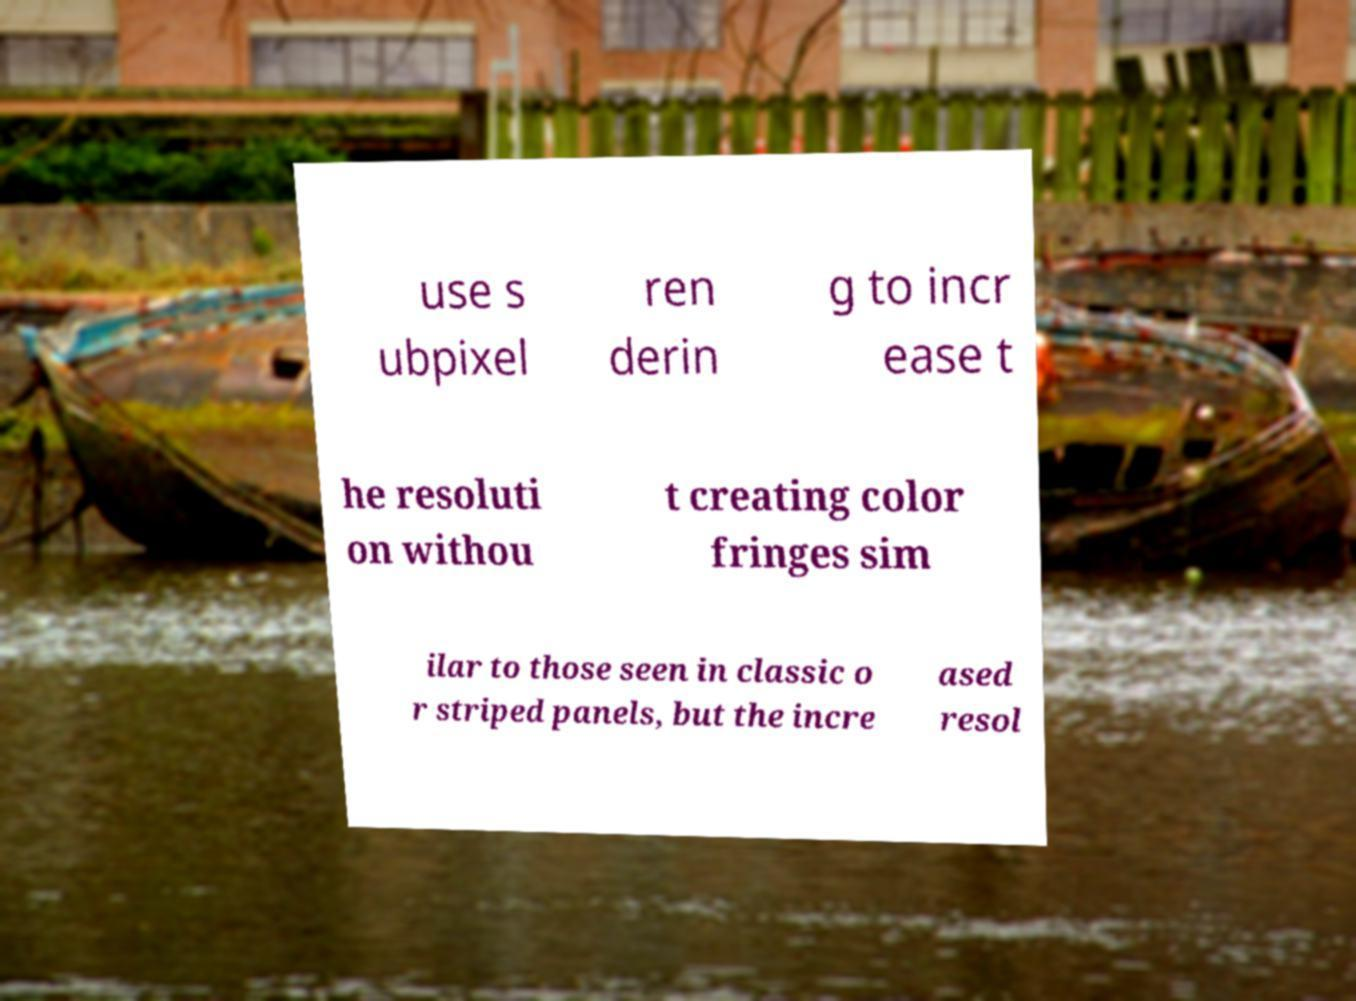Please identify and transcribe the text found in this image. use s ubpixel ren derin g to incr ease t he resoluti on withou t creating color fringes sim ilar to those seen in classic o r striped panels, but the incre ased resol 